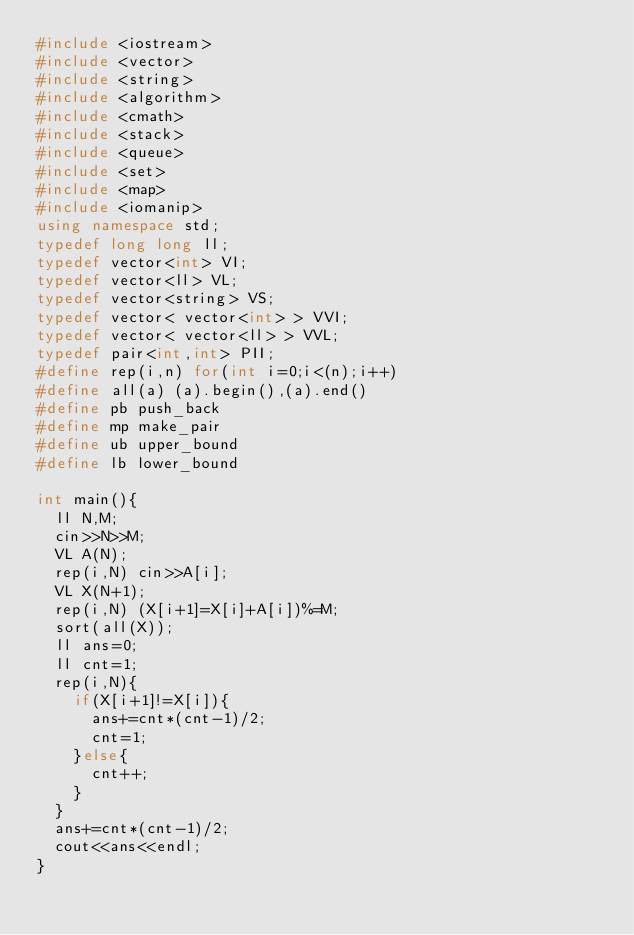<code> <loc_0><loc_0><loc_500><loc_500><_C++_>#include <iostream>
#include <vector>
#include <string>
#include <algorithm>
#include <cmath>
#include <stack>
#include <queue>
#include <set>
#include <map>
#include <iomanip>
using namespace std;
typedef long long ll;
typedef vector<int> VI;
typedef vector<ll> VL;
typedef vector<string> VS;
typedef vector< vector<int> > VVI;
typedef vector< vector<ll> > VVL;
typedef pair<int,int> PII;
#define rep(i,n) for(int i=0;i<(n);i++)
#define all(a) (a).begin(),(a).end()
#define pb push_back
#define mp make_pair
#define ub upper_bound
#define lb lower_bound

int main(){
  ll N,M;
  cin>>N>>M;
  VL A(N);
  rep(i,N) cin>>A[i];
  VL X(N+1);
  rep(i,N) (X[i+1]=X[i]+A[i])%=M;
  sort(all(X));
  ll ans=0;
  ll cnt=1;
  rep(i,N){
    if(X[i+1]!=X[i]){
      ans+=cnt*(cnt-1)/2;
      cnt=1;
    }else{
      cnt++;
    }
  }
  ans+=cnt*(cnt-1)/2;
  cout<<ans<<endl;
}</code> 